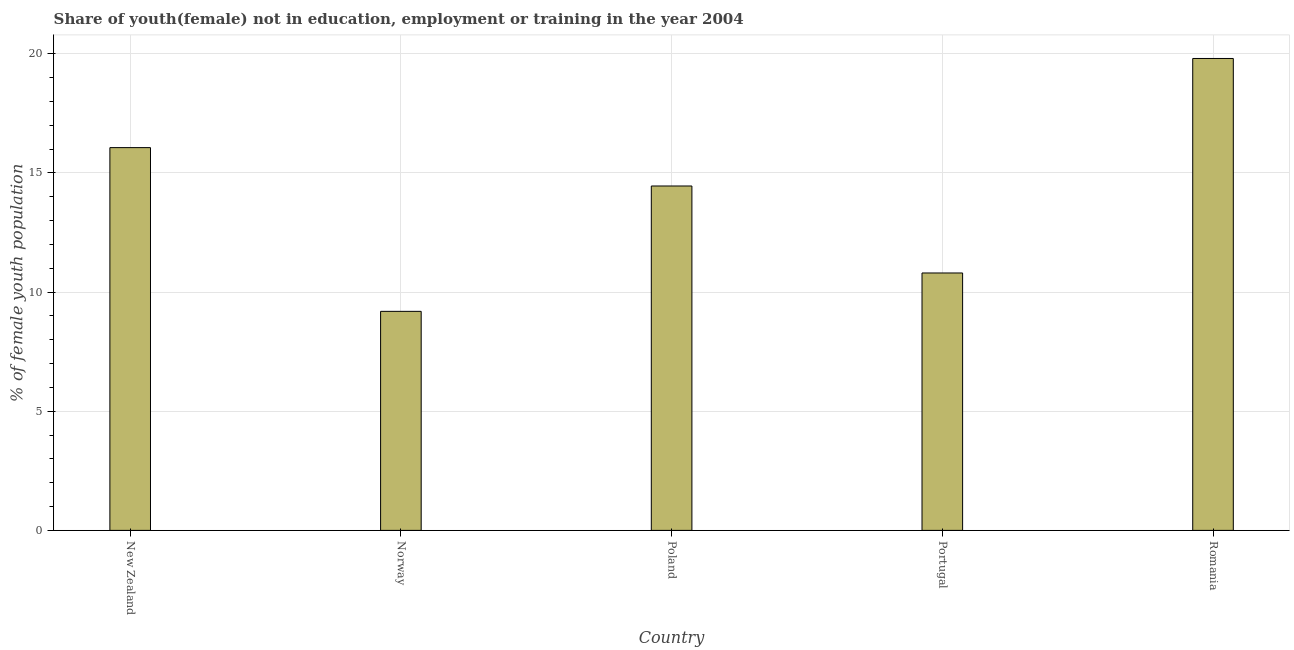Does the graph contain grids?
Ensure brevity in your answer.  Yes. What is the title of the graph?
Provide a short and direct response. Share of youth(female) not in education, employment or training in the year 2004. What is the label or title of the X-axis?
Your answer should be compact. Country. What is the label or title of the Y-axis?
Provide a succinct answer. % of female youth population. What is the unemployed female youth population in Poland?
Provide a short and direct response. 14.45. Across all countries, what is the maximum unemployed female youth population?
Your answer should be compact. 19.8. Across all countries, what is the minimum unemployed female youth population?
Keep it short and to the point. 9.19. In which country was the unemployed female youth population maximum?
Ensure brevity in your answer.  Romania. In which country was the unemployed female youth population minimum?
Offer a terse response. Norway. What is the sum of the unemployed female youth population?
Keep it short and to the point. 70.3. What is the difference between the unemployed female youth population in New Zealand and Romania?
Give a very brief answer. -3.74. What is the average unemployed female youth population per country?
Give a very brief answer. 14.06. What is the median unemployed female youth population?
Provide a succinct answer. 14.45. In how many countries, is the unemployed female youth population greater than 7 %?
Give a very brief answer. 5. What is the ratio of the unemployed female youth population in New Zealand to that in Norway?
Ensure brevity in your answer.  1.75. Is the difference between the unemployed female youth population in Norway and Portugal greater than the difference between any two countries?
Your answer should be very brief. No. What is the difference between the highest and the second highest unemployed female youth population?
Your response must be concise. 3.74. Is the sum of the unemployed female youth population in Portugal and Romania greater than the maximum unemployed female youth population across all countries?
Offer a terse response. Yes. What is the difference between the highest and the lowest unemployed female youth population?
Your answer should be very brief. 10.61. Are all the bars in the graph horizontal?
Your answer should be compact. No. What is the % of female youth population in New Zealand?
Your response must be concise. 16.06. What is the % of female youth population of Norway?
Provide a succinct answer. 9.19. What is the % of female youth population of Poland?
Make the answer very short. 14.45. What is the % of female youth population of Portugal?
Keep it short and to the point. 10.8. What is the % of female youth population of Romania?
Offer a terse response. 19.8. What is the difference between the % of female youth population in New Zealand and Norway?
Your answer should be very brief. 6.87. What is the difference between the % of female youth population in New Zealand and Poland?
Provide a succinct answer. 1.61. What is the difference between the % of female youth population in New Zealand and Portugal?
Provide a succinct answer. 5.26. What is the difference between the % of female youth population in New Zealand and Romania?
Provide a succinct answer. -3.74. What is the difference between the % of female youth population in Norway and Poland?
Ensure brevity in your answer.  -5.26. What is the difference between the % of female youth population in Norway and Portugal?
Offer a terse response. -1.61. What is the difference between the % of female youth population in Norway and Romania?
Your answer should be compact. -10.61. What is the difference between the % of female youth population in Poland and Portugal?
Your answer should be compact. 3.65. What is the difference between the % of female youth population in Poland and Romania?
Ensure brevity in your answer.  -5.35. What is the ratio of the % of female youth population in New Zealand to that in Norway?
Provide a short and direct response. 1.75. What is the ratio of the % of female youth population in New Zealand to that in Poland?
Make the answer very short. 1.11. What is the ratio of the % of female youth population in New Zealand to that in Portugal?
Offer a very short reply. 1.49. What is the ratio of the % of female youth population in New Zealand to that in Romania?
Provide a succinct answer. 0.81. What is the ratio of the % of female youth population in Norway to that in Poland?
Provide a short and direct response. 0.64. What is the ratio of the % of female youth population in Norway to that in Portugal?
Give a very brief answer. 0.85. What is the ratio of the % of female youth population in Norway to that in Romania?
Give a very brief answer. 0.46. What is the ratio of the % of female youth population in Poland to that in Portugal?
Provide a succinct answer. 1.34. What is the ratio of the % of female youth population in Poland to that in Romania?
Keep it short and to the point. 0.73. What is the ratio of the % of female youth population in Portugal to that in Romania?
Your answer should be compact. 0.55. 